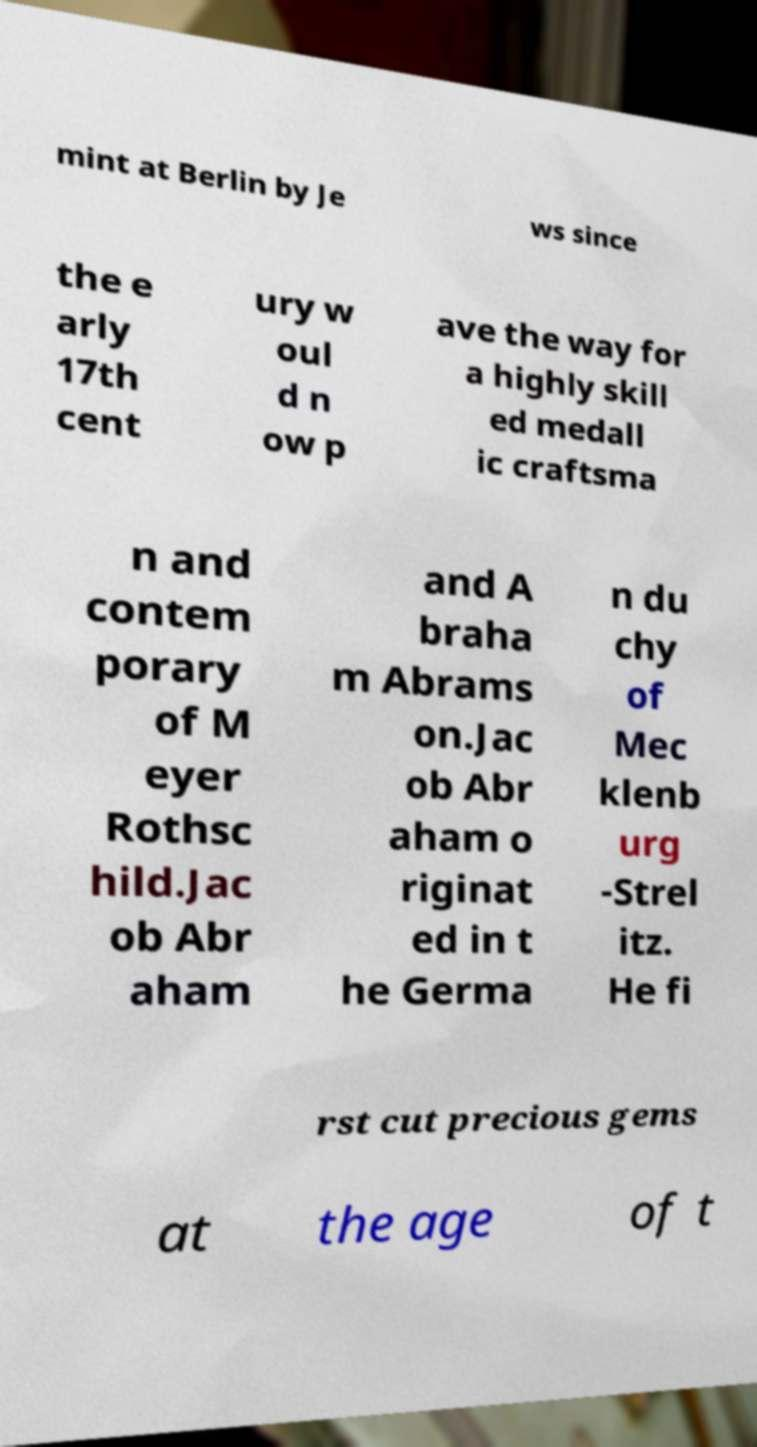Could you assist in decoding the text presented in this image and type it out clearly? mint at Berlin by Je ws since the e arly 17th cent ury w oul d n ow p ave the way for a highly skill ed medall ic craftsma n and contem porary of M eyer Rothsc hild.Jac ob Abr aham and A braha m Abrams on.Jac ob Abr aham o riginat ed in t he Germa n du chy of Mec klenb urg -Strel itz. He fi rst cut precious gems at the age of t 